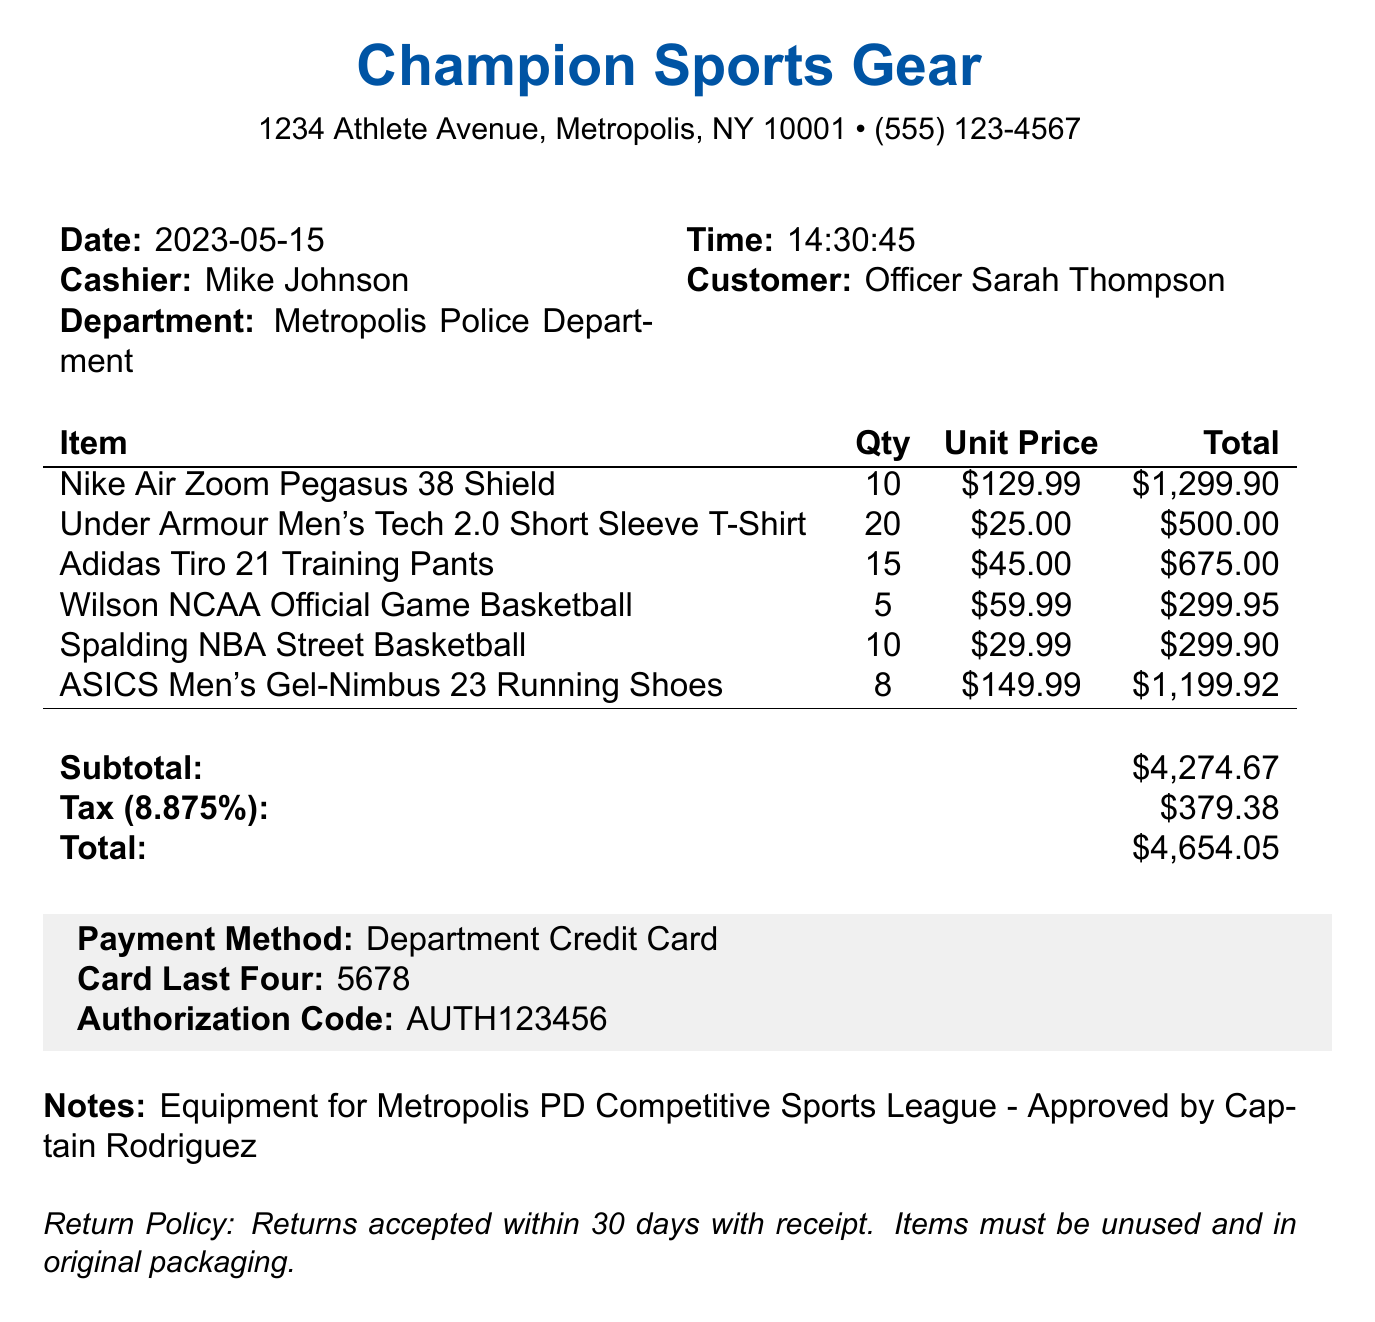What is the store name? The store name is listed at the top of the document, indicating where the transaction took place.
Answer: Champion Sports Gear What is the date of the transaction? The date of the transaction is provided in the header section of the document.
Answer: 2023-05-15 Who is the cashier? The name of the cashier can be found in the transaction details section.
Answer: Mike Johnson How many Adidas Tiro 21 Training Pants were purchased? The quantity of the specific item can be found in the itemized list provided in the document.
Answer: 15 What is the total tax amount? The total tax amount is mentioned at the bottom of the document, summing the applicable tax on the subtotal.
Answer: 379.38 What is the subtotal before tax? The subtotal is calculated from all items before taxes are added and is found in the document.
Answer: 4274.67 How many Nike Air Zoom Pegasus 38 Shields were bought in total? The total quantity of this specific item is shown in the itemized list of the document.
Answer: 10 What payment method was used? The payment method is detailed in the payment information section of the document.
Answer: Department Credit Card What is the return policy for the items? The return policy is specified at the end of the document, detailing the conditions for return.
Answer: Returns accepted within 30 days with receipt. Items must be unused and in original packaging 